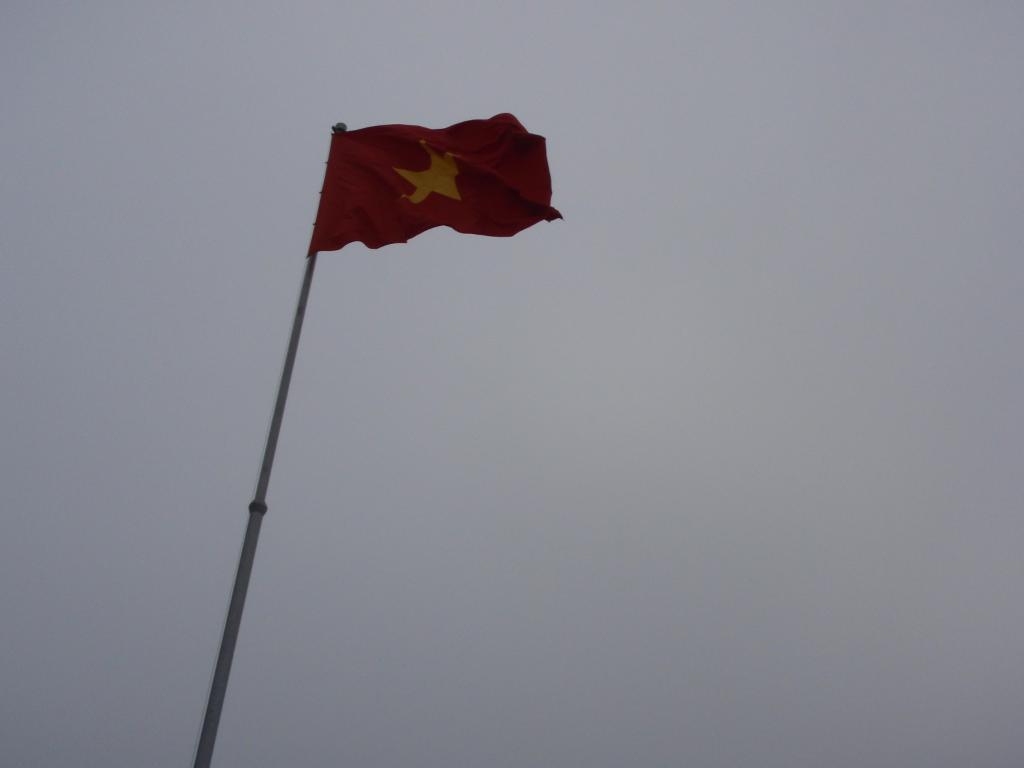Please provide a concise description of this image. There is a red color flag which has a yellow color star mark on it is attached to a pole and the sky is cloudy. 